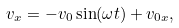Convert formula to latex. <formula><loc_0><loc_0><loc_500><loc_500>v _ { x } = - v _ { 0 } \sin ( \omega t ) + v _ { 0 x } ,</formula> 